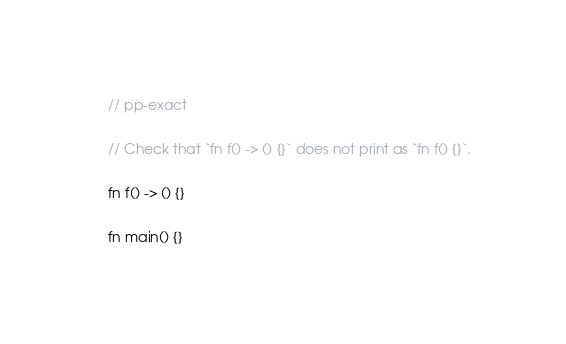<code> <loc_0><loc_0><loc_500><loc_500><_Rust_>// pp-exact

// Check that `fn f() -> () {}` does not print as `fn f() {}`.

fn f() -> () {}

fn main() {}
</code> 